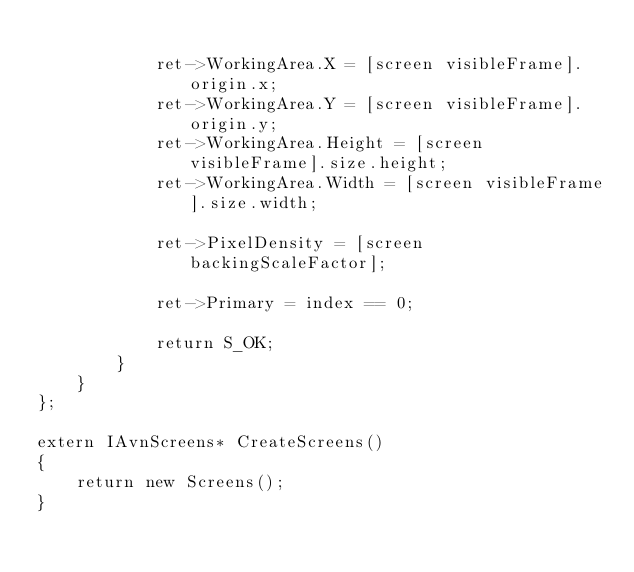<code> <loc_0><loc_0><loc_500><loc_500><_ObjectiveC_>            
            ret->WorkingArea.X = [screen visibleFrame].origin.x;
            ret->WorkingArea.Y = [screen visibleFrame].origin.y;
            ret->WorkingArea.Height = [screen visibleFrame].size.height;
            ret->WorkingArea.Width = [screen visibleFrame].size.width;
            
            ret->PixelDensity = [screen backingScaleFactor];
            
            ret->Primary = index == 0;
            
            return S_OK;
        }
    }
};

extern IAvnScreens* CreateScreens()
{
    return new Screens();
}
</code> 